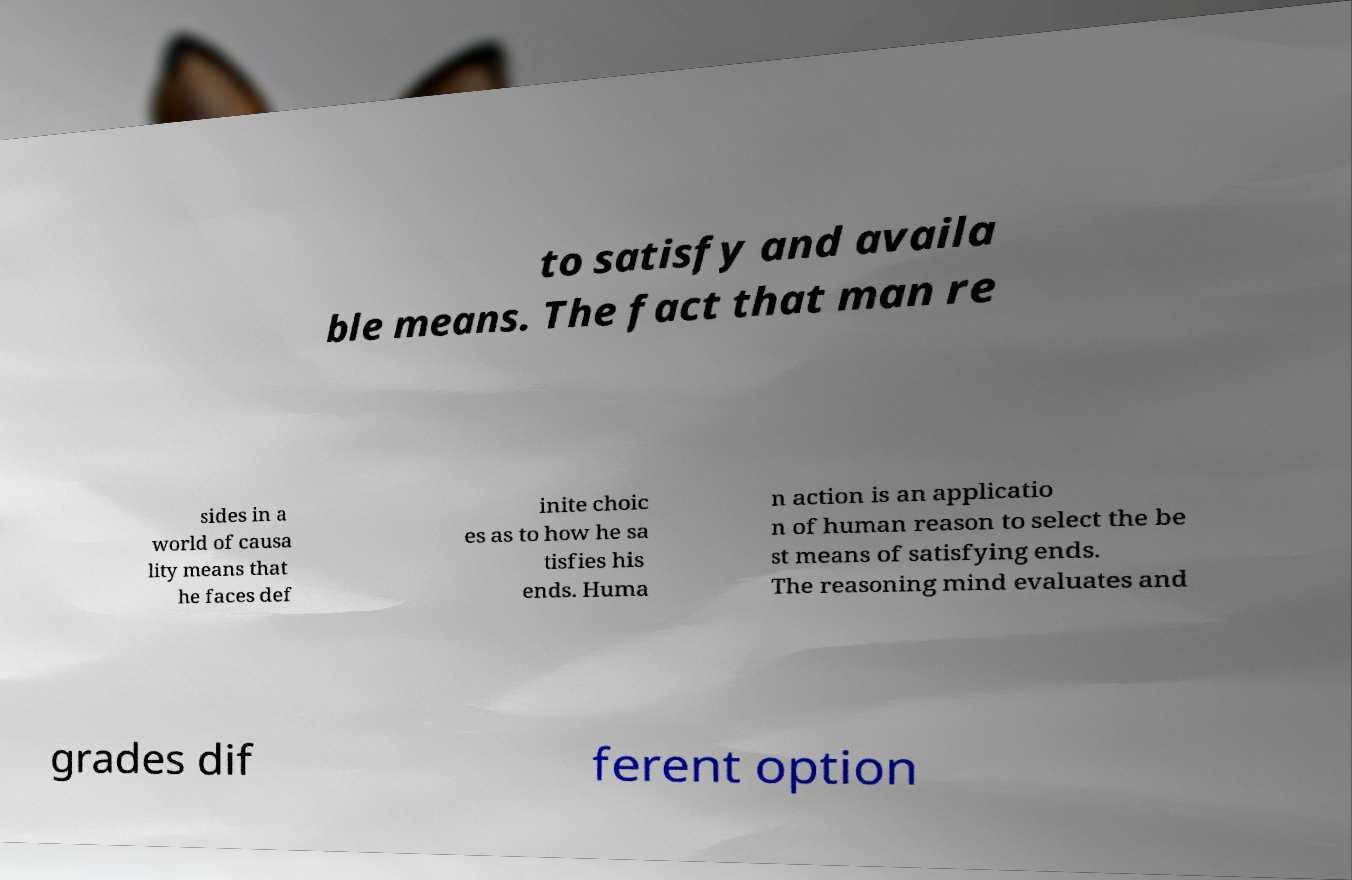There's text embedded in this image that I need extracted. Can you transcribe it verbatim? to satisfy and availa ble means. The fact that man re sides in a world of causa lity means that he faces def inite choic es as to how he sa tisfies his ends. Huma n action is an applicatio n of human reason to select the be st means of satisfying ends. The reasoning mind evaluates and grades dif ferent option 